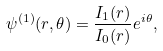Convert formula to latex. <formula><loc_0><loc_0><loc_500><loc_500>\psi ^ { ( 1 ) } ( r , \theta ) = \frac { I _ { 1 } ( r ) } { I _ { 0 } ( r ) } e ^ { i \theta } ,</formula> 